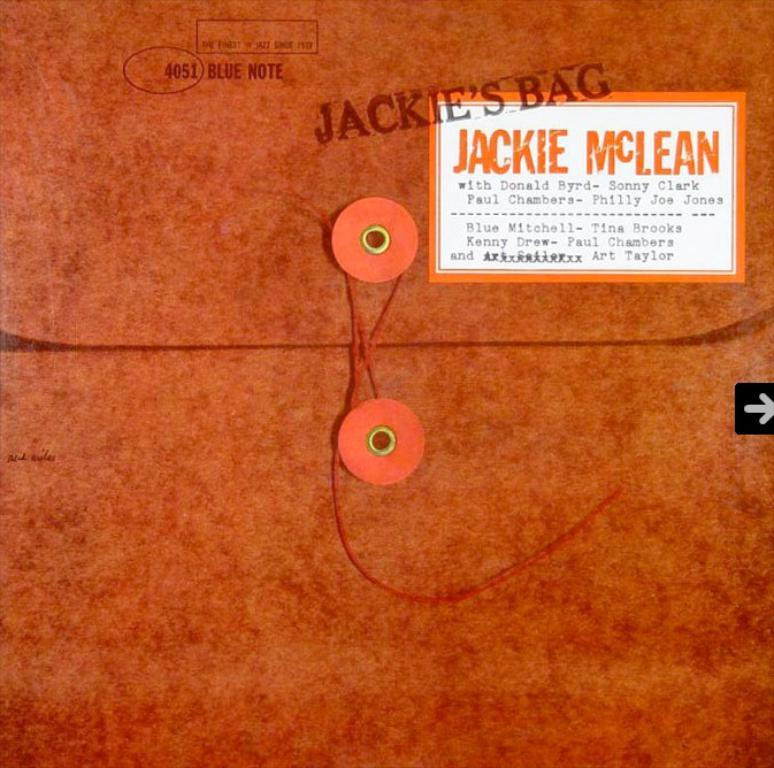<image>
Describe the image concisely. A brown case that apparently belongs to Jackie McLean. 